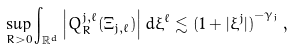<formula> <loc_0><loc_0><loc_500><loc_500>\sup _ { R > 0 } \int _ { \mathbb { R } ^ { d } } \left | Q _ { R } ^ { j , \ell } ( \Xi _ { j , \ell } ) \right | d \xi ^ { \ell } \lesssim { ( 1 + | \xi ^ { j } | ) } ^ { - \gamma _ { j } } \, ,</formula> 